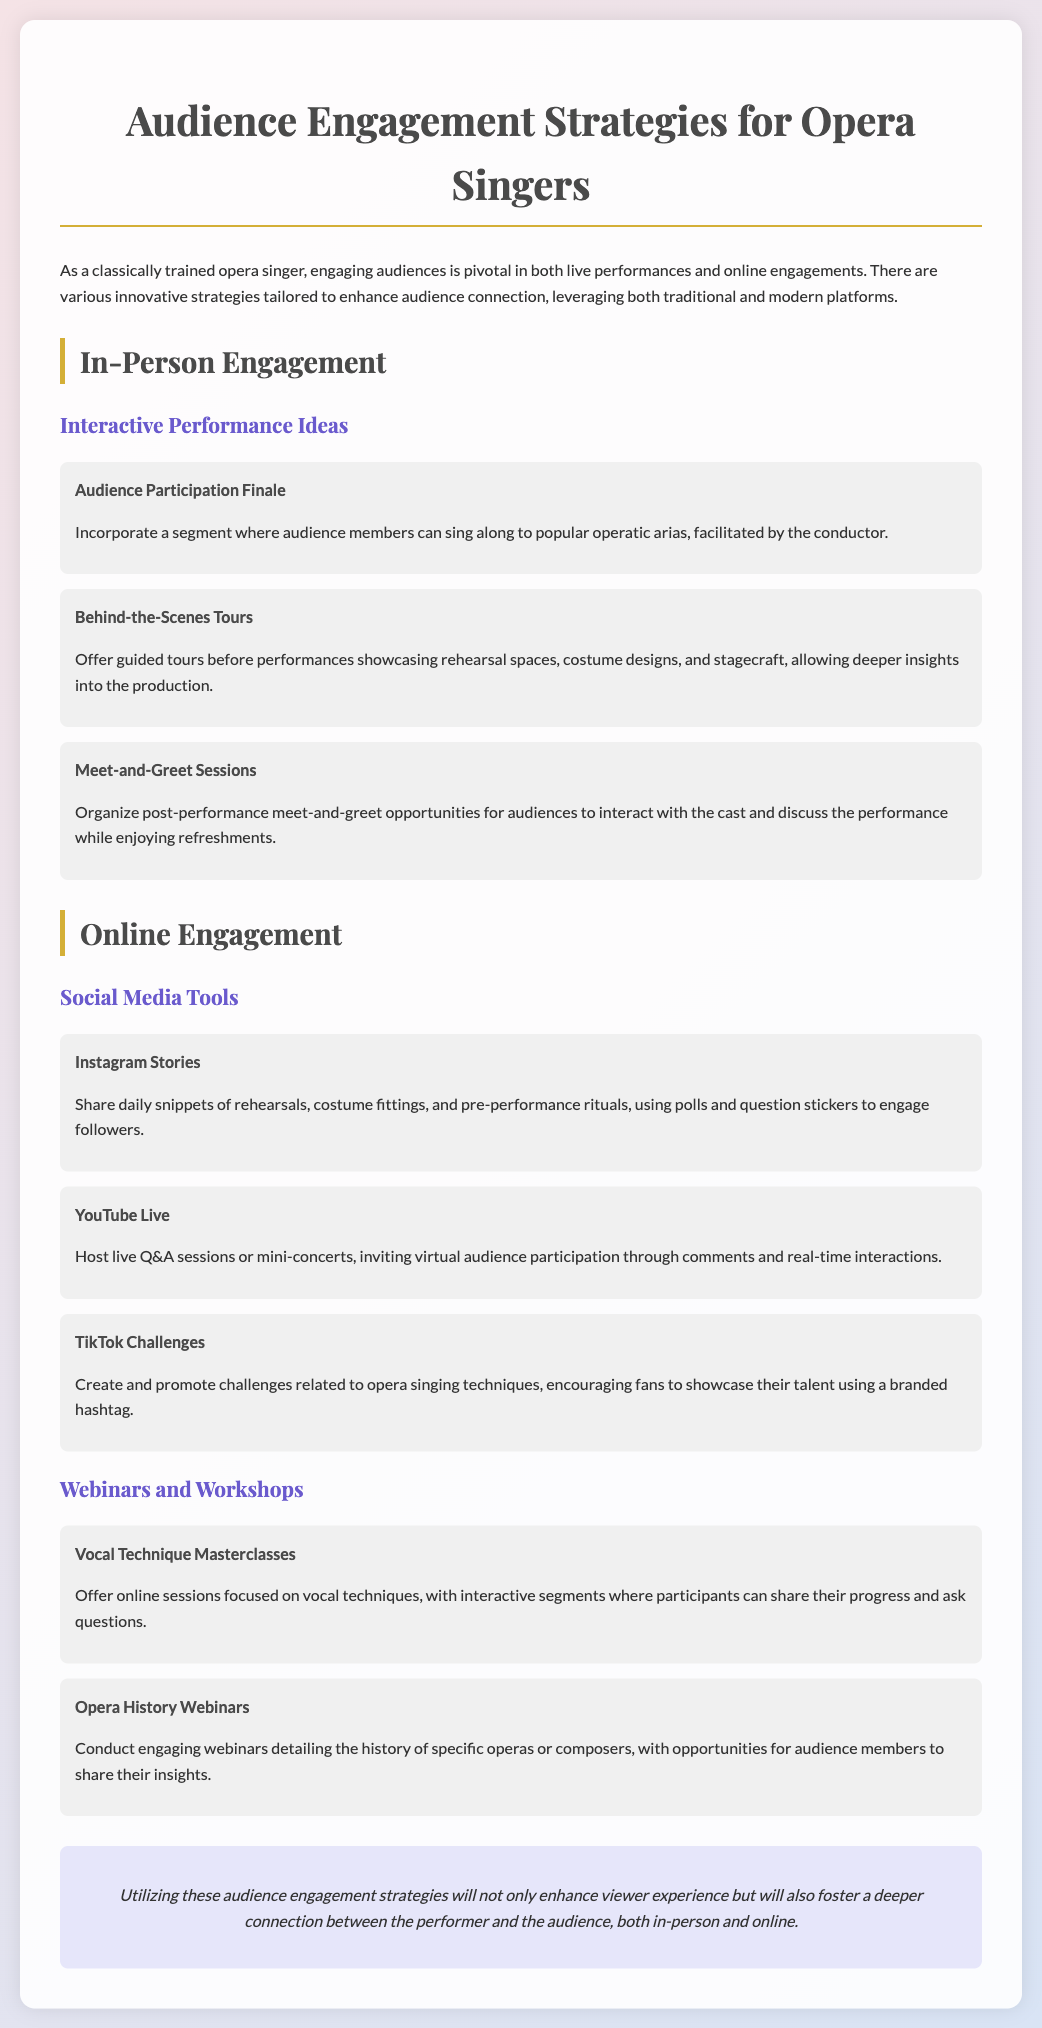What is the title of the document? The title of the document is stated clearly at the beginning, emphasizing its focus on engagement strategies for opera singers.
Answer: Audience Engagement Strategies for Opera Singers What are two interactive performance ideas listed for in-person engagement? Two specific ideas are included under in-person engagement to enhance audience interaction.
Answer: Audience Participation Finale, Meet-and-Greet Sessions What social media tool is suggested to share daily snippets? The document specifies a specific social media platform useful for sharing behind-the-scenes content.
Answer: Instagram Stories How many webinars and workshops are mentioned? The document outlines specific educational opportunities categorized under webinars and workshops.
Answer: Two What is one purpose of offering behind-the-scenes tours? The document explains how this strategy allows for a more profound audience experience by offering insights.
Answer: Deeper insights into the production What color is used for the strategy titles? The document uses a particular color to draw attention to the titles of strategies, enhancing readability.
Answer: #4a4a4a What type of session does a vocal technique masterclass refer to? This term in the document describes a format focusing on skill enhancement and interactive learning.
Answer: Online session Which platform is mentioned for hosting live Q&A sessions? The document identifies a specific platform for real-time audience interaction during live events.
Answer: YouTube Live 